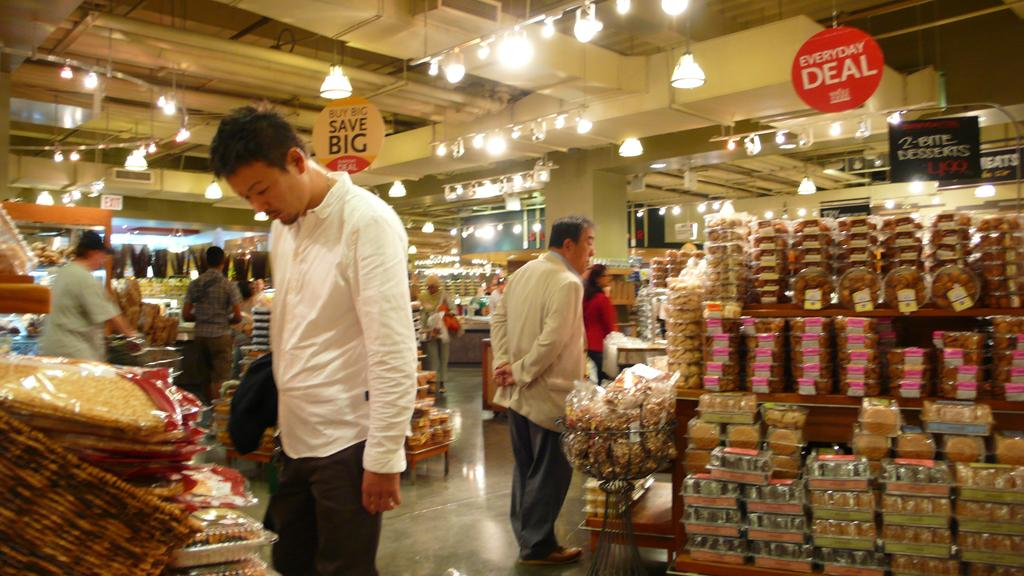Provide a one-sentence caption for the provided image. Shoppers looking through the everyday deal sections to save big. 